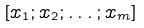<formula> <loc_0><loc_0><loc_500><loc_500>[ x _ { 1 } ; x _ { 2 } ; \dots ; x _ { m } ]</formula> 